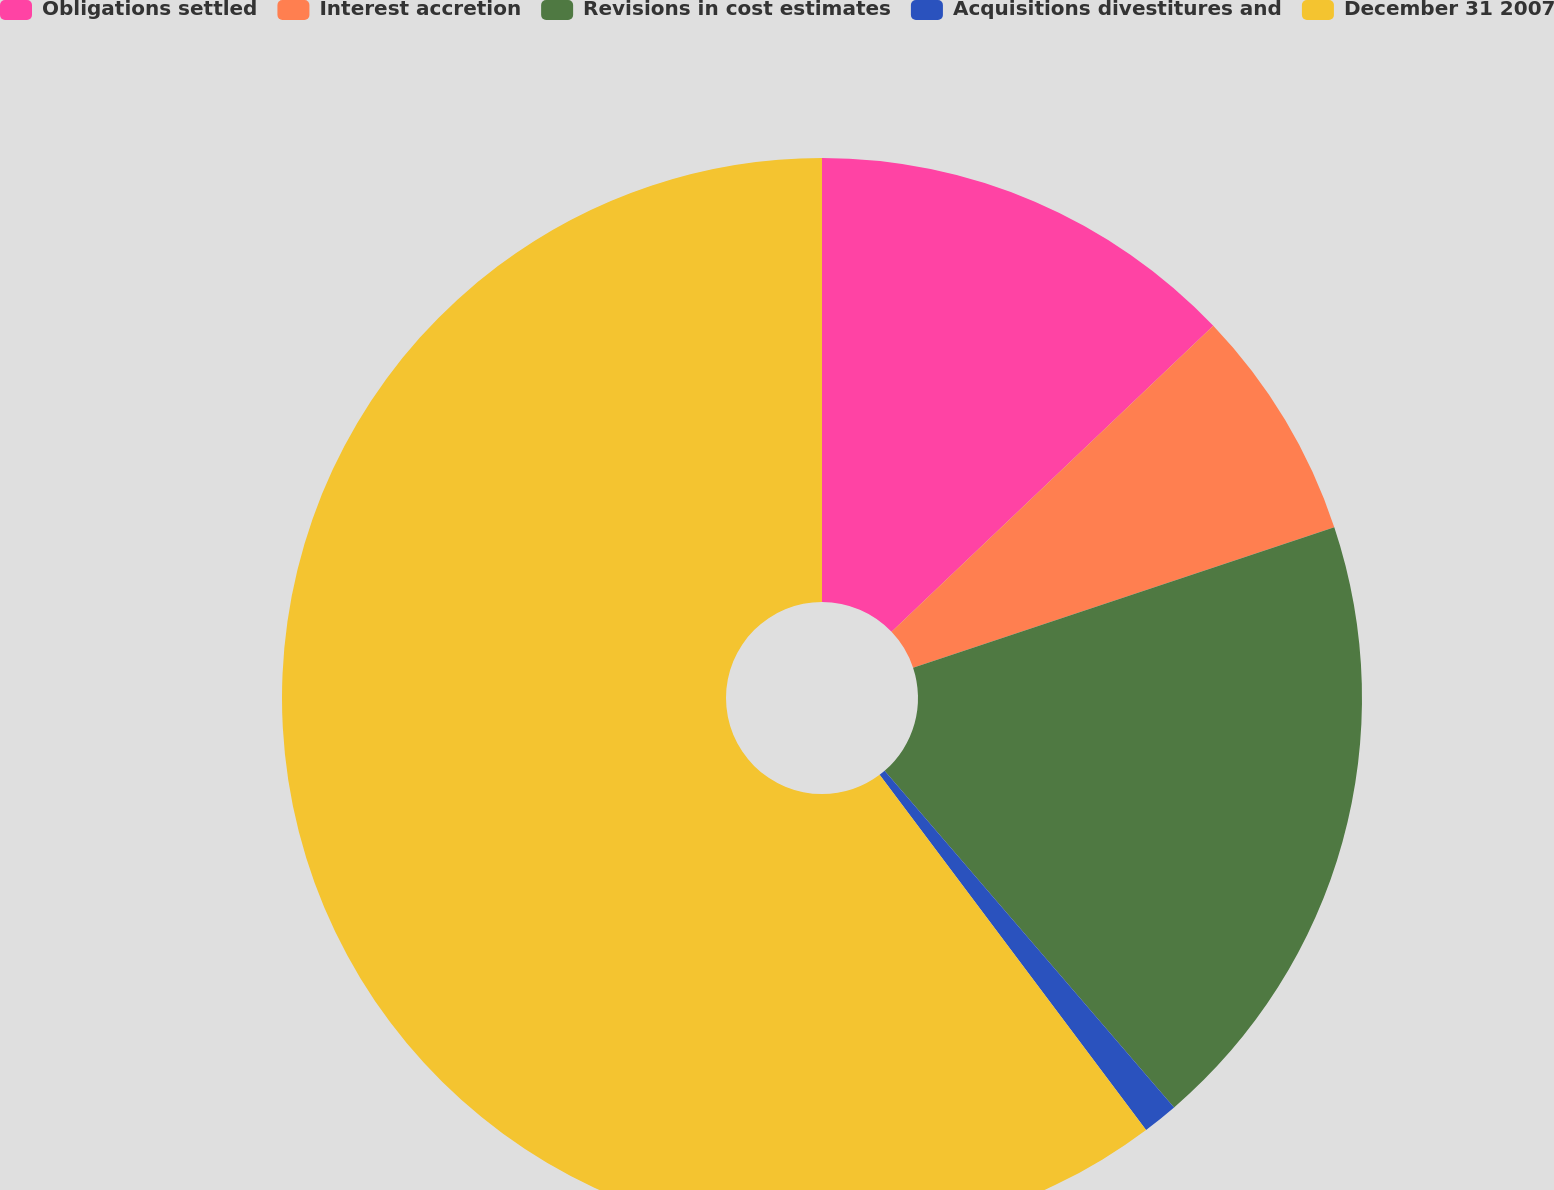Convert chart. <chart><loc_0><loc_0><loc_500><loc_500><pie_chart><fcel>Obligations settled<fcel>Interest accretion<fcel>Revisions in cost estimates<fcel>Acquisitions divestitures and<fcel>December 31 2007<nl><fcel>12.9%<fcel>6.98%<fcel>18.82%<fcel>1.06%<fcel>60.25%<nl></chart> 